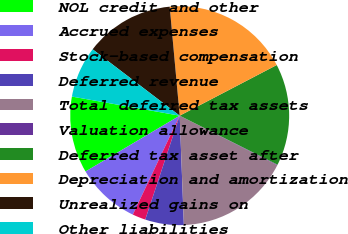<chart> <loc_0><loc_0><loc_500><loc_500><pie_chart><fcel>NOL credit and other<fcel>Accrued expenses<fcel>Stock-based compensation<fcel>Deferred revenue<fcel>Total deferred tax assets<fcel>Valuation allowance<fcel>Deferred tax asset after<fcel>Depreciation and amortization<fcel>Unrealized gains on<fcel>Other liabilities<nl><fcel>11.31%<fcel>9.44%<fcel>1.95%<fcel>5.7%<fcel>16.92%<fcel>0.08%<fcel>15.05%<fcel>18.8%<fcel>13.18%<fcel>7.57%<nl></chart> 